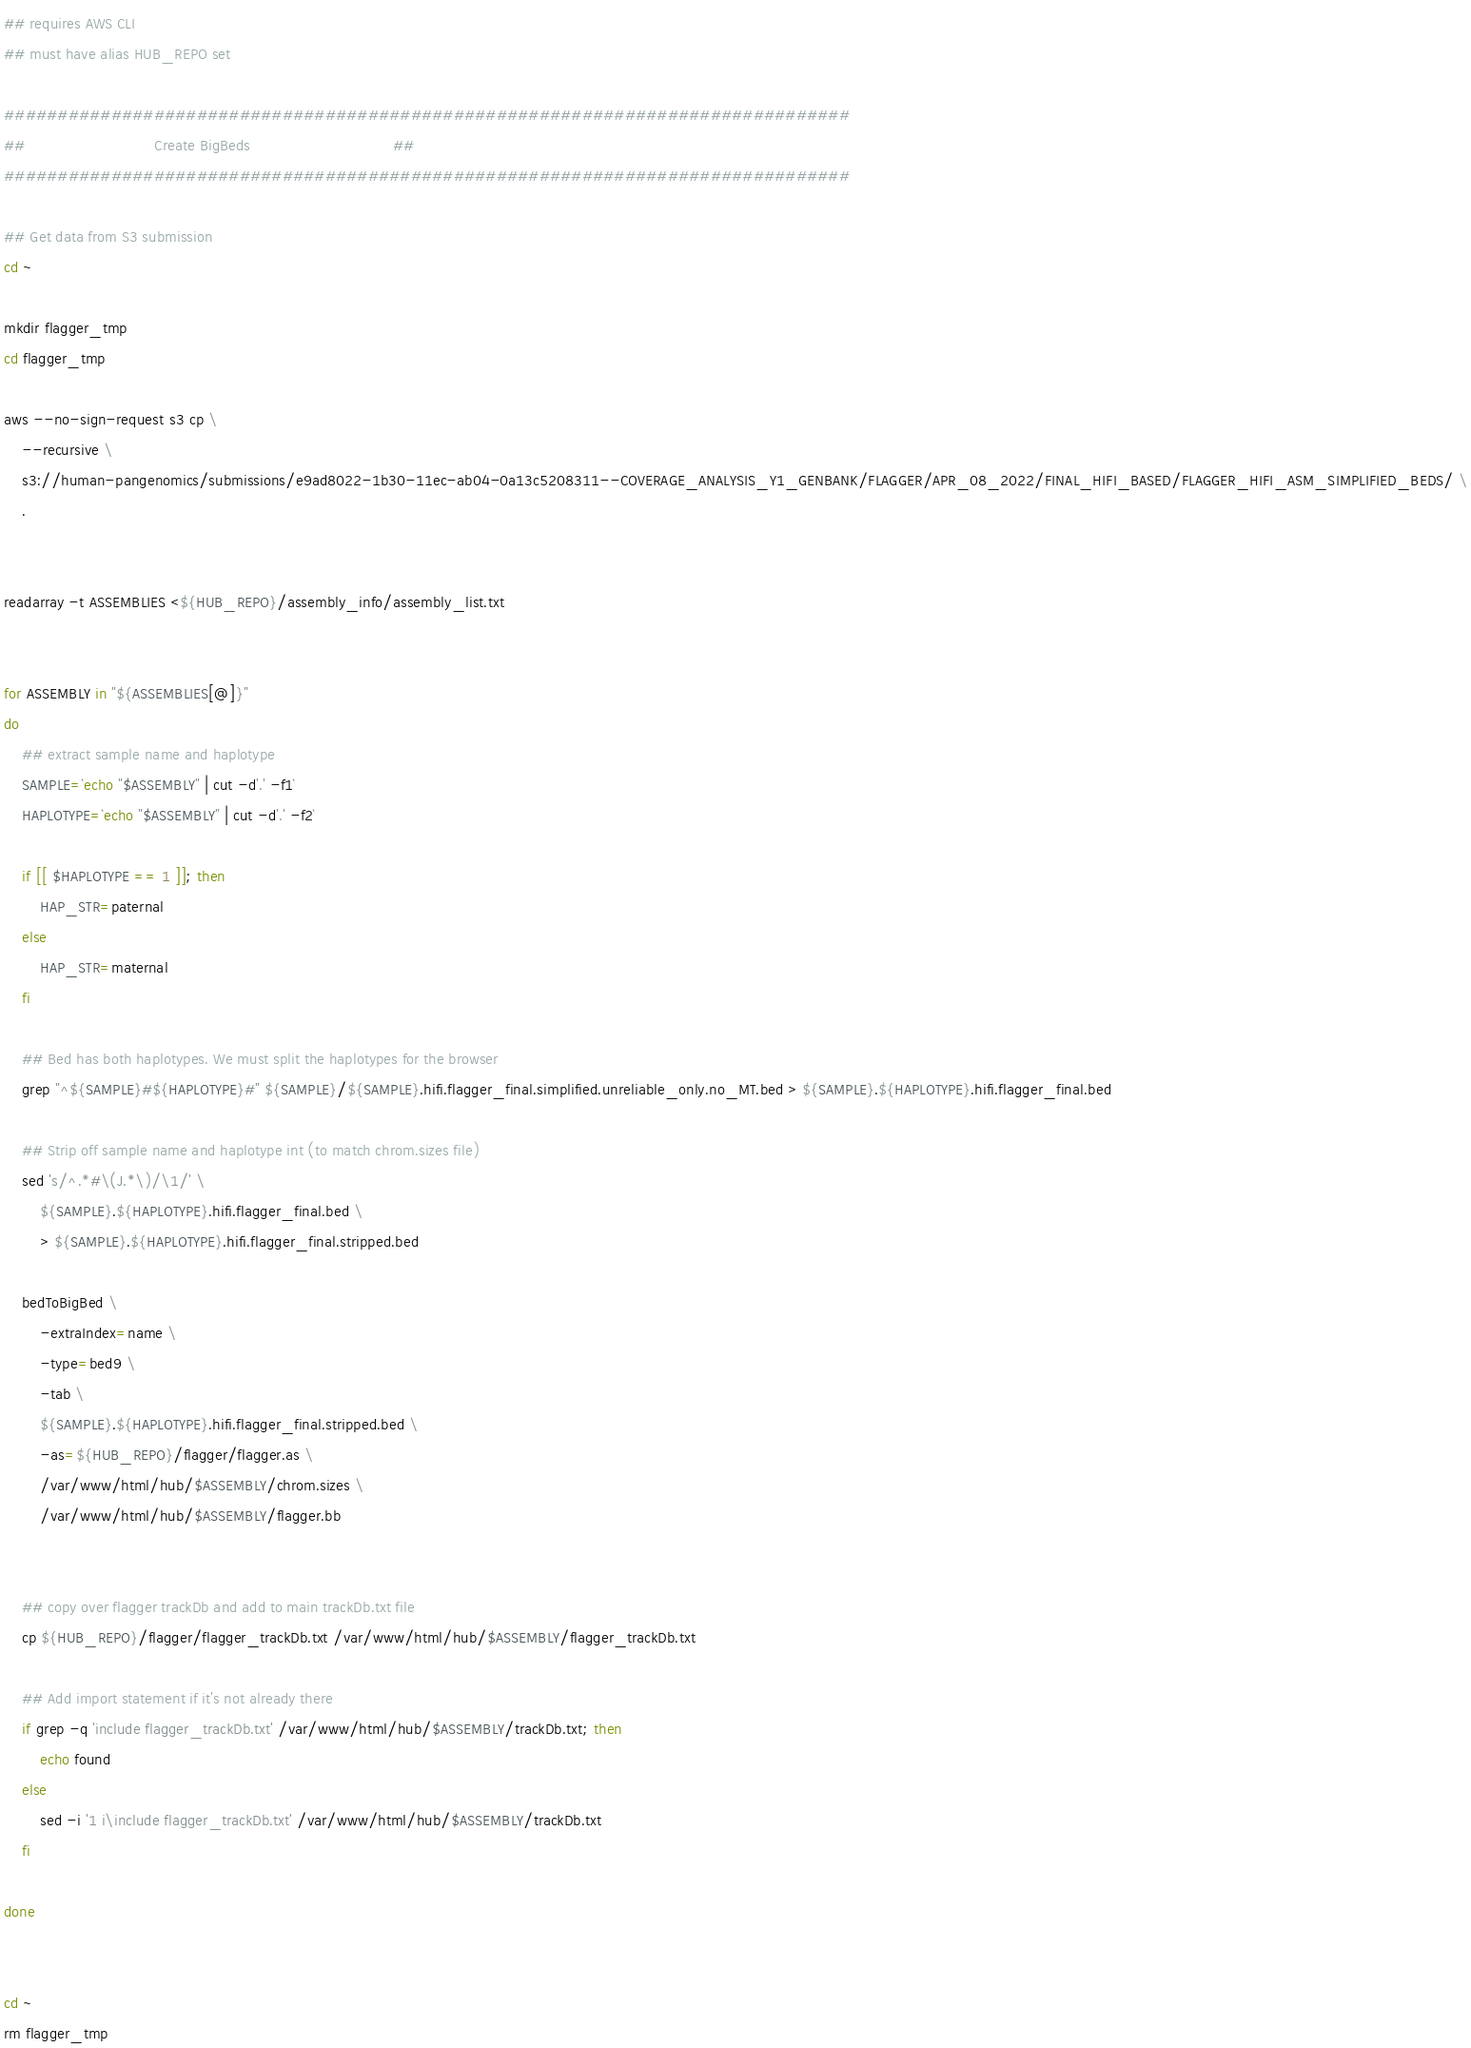Convert code to text. <code><loc_0><loc_0><loc_500><loc_500><_Bash_>## requires AWS CLI
## must have alias HUB_REPO set

############################################################################### 
##                             Create BigBeds                                ##
###############################################################################

## Get data from S3 submission
cd ~

mkdir flagger_tmp
cd flagger_tmp

aws --no-sign-request s3 cp \
    --recursive \
    s3://human-pangenomics/submissions/e9ad8022-1b30-11ec-ab04-0a13c5208311--COVERAGE_ANALYSIS_Y1_GENBANK/FLAGGER/APR_08_2022/FINAL_HIFI_BASED/FLAGGER_HIFI_ASM_SIMPLIFIED_BEDS/ \
    .


readarray -t ASSEMBLIES <${HUB_REPO}/assembly_info/assembly_list.txt


for ASSEMBLY in "${ASSEMBLIES[@]}"
do 
    ## extract sample name and haplotype
    SAMPLE=`echo "$ASSEMBLY" | cut -d'.' -f1`
    HAPLOTYPE=`echo "$ASSEMBLY" | cut -d'.' -f2`

    if [[ $HAPLOTYPE == 1 ]]; then
        HAP_STR=paternal
    else 
        HAP_STR=maternal
    fi

    ## Bed has both haplotypes. We must split the haplotypes for the browser
    grep "^${SAMPLE}#${HAPLOTYPE}#" ${SAMPLE}/${SAMPLE}.hifi.flagger_final.simplified.unreliable_only.no_MT.bed > ${SAMPLE}.${HAPLOTYPE}.hifi.flagger_final.bed

    ## Strip off sample name and haplotype int (to match chrom.sizes file)
    sed 's/^.*#\(J.*\)/\1/' \
        ${SAMPLE}.${HAPLOTYPE}.hifi.flagger_final.bed \
        > ${SAMPLE}.${HAPLOTYPE}.hifi.flagger_final.stripped.bed

    bedToBigBed \
        -extraIndex=name \
        -type=bed9 \
        -tab \
        ${SAMPLE}.${HAPLOTYPE}.hifi.flagger_final.stripped.bed \
        -as=${HUB_REPO}/flagger/flagger.as \
        /var/www/html/hub/$ASSEMBLY/chrom.sizes \
        /var/www/html/hub/$ASSEMBLY/flagger.bb


    ## copy over flagger trackDb and add to main trackDb.txt file
    cp ${HUB_REPO}/flagger/flagger_trackDb.txt /var/www/html/hub/$ASSEMBLY/flagger_trackDb.txt 

    ## Add import statement if it's not already there
    if grep -q 'include flagger_trackDb.txt' /var/www/html/hub/$ASSEMBLY/trackDb.txt; then
        echo found
    else
        sed -i '1 i\include flagger_trackDb.txt' /var/www/html/hub/$ASSEMBLY/trackDb.txt
    fi

done


cd ~
rm flagger_tmp

</code> 